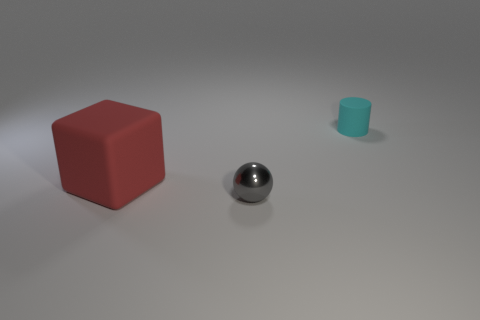There is a cylinder that is the same material as the cube; what is its size?
Keep it short and to the point. Small. The red rubber block has what size?
Your response must be concise. Large. Do the small cylinder and the red block have the same material?
Ensure brevity in your answer.  Yes. How many cylinders are shiny things or red matte objects?
Offer a very short reply. 0. What color is the thing on the left side of the small thing that is in front of the large matte thing?
Your response must be concise. Red. There is a rubber object that is to the right of the rubber thing in front of the cyan rubber cylinder; what number of cylinders are in front of it?
Provide a short and direct response. 0. There is a tiny thing that is on the right side of the tiny ball; does it have the same shape as the rubber object to the left of the tiny cylinder?
Offer a very short reply. No. What number of objects are tiny gray matte cubes or rubber things?
Offer a very short reply. 2. What is the material of the small thing that is to the left of the thing on the right side of the gray metal thing?
Your answer should be very brief. Metal. Is there a big rubber cylinder that has the same color as the shiny ball?
Your answer should be compact. No. 